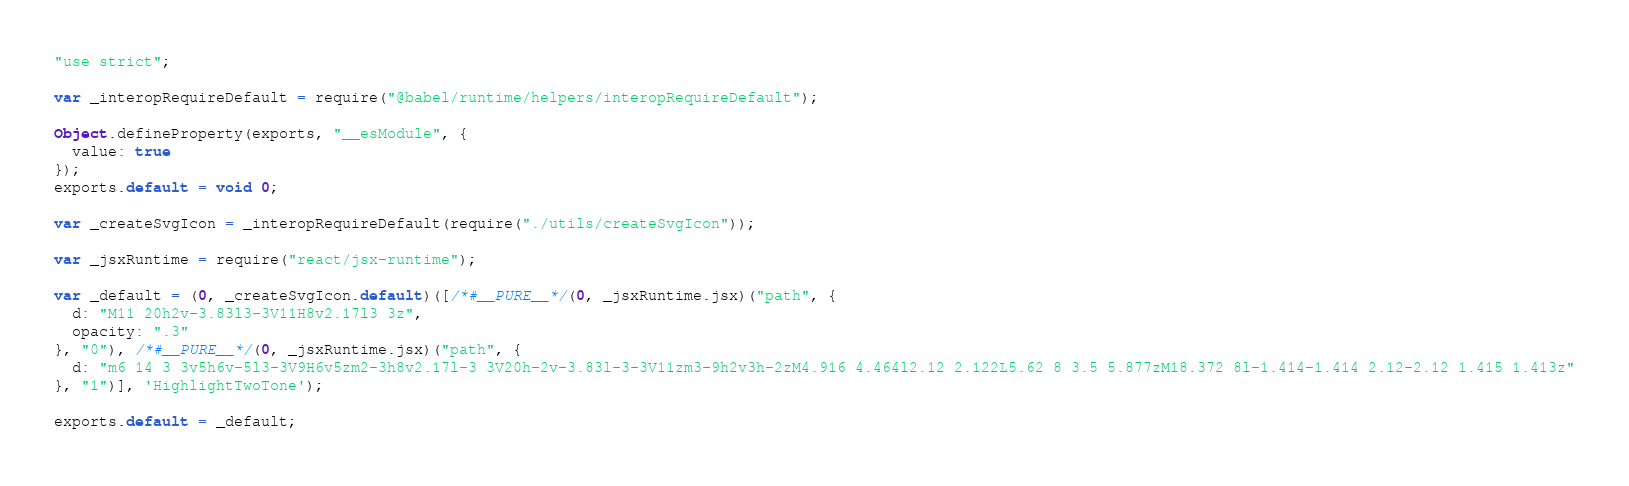Convert code to text. <code><loc_0><loc_0><loc_500><loc_500><_JavaScript_>"use strict";

var _interopRequireDefault = require("@babel/runtime/helpers/interopRequireDefault");

Object.defineProperty(exports, "__esModule", {
  value: true
});
exports.default = void 0;

var _createSvgIcon = _interopRequireDefault(require("./utils/createSvgIcon"));

var _jsxRuntime = require("react/jsx-runtime");

var _default = (0, _createSvgIcon.default)([/*#__PURE__*/(0, _jsxRuntime.jsx)("path", {
  d: "M11 20h2v-3.83l3-3V11H8v2.17l3 3z",
  opacity: ".3"
}, "0"), /*#__PURE__*/(0, _jsxRuntime.jsx)("path", {
  d: "m6 14 3 3v5h6v-5l3-3V9H6v5zm2-3h8v2.17l-3 3V20h-2v-3.83l-3-3V11zm3-9h2v3h-2zM4.916 4.464l2.12 2.122L5.62 8 3.5 5.877zM18.372 8l-1.414-1.414 2.12-2.12 1.415 1.413z"
}, "1")], 'HighlightTwoTone');

exports.default = _default;</code> 